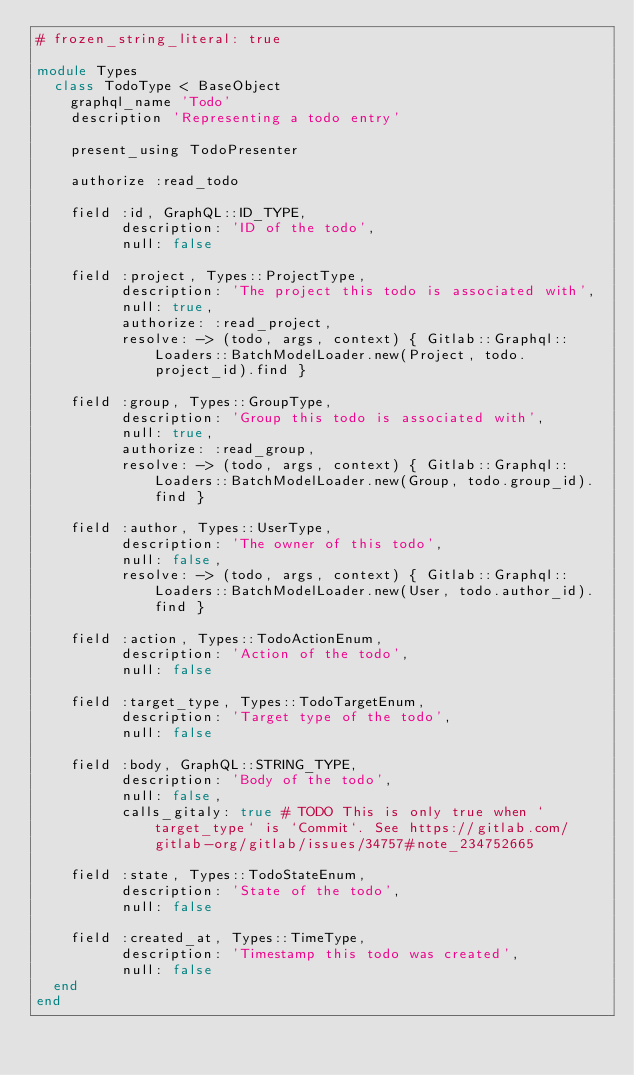<code> <loc_0><loc_0><loc_500><loc_500><_Ruby_># frozen_string_literal: true

module Types
  class TodoType < BaseObject
    graphql_name 'Todo'
    description 'Representing a todo entry'

    present_using TodoPresenter

    authorize :read_todo

    field :id, GraphQL::ID_TYPE,
          description: 'ID of the todo',
          null: false

    field :project, Types::ProjectType,
          description: 'The project this todo is associated with',
          null: true,
          authorize: :read_project,
          resolve: -> (todo, args, context) { Gitlab::Graphql::Loaders::BatchModelLoader.new(Project, todo.project_id).find }

    field :group, Types::GroupType,
          description: 'Group this todo is associated with',
          null: true,
          authorize: :read_group,
          resolve: -> (todo, args, context) { Gitlab::Graphql::Loaders::BatchModelLoader.new(Group, todo.group_id).find }

    field :author, Types::UserType,
          description: 'The owner of this todo',
          null: false,
          resolve: -> (todo, args, context) { Gitlab::Graphql::Loaders::BatchModelLoader.new(User, todo.author_id).find }

    field :action, Types::TodoActionEnum,
          description: 'Action of the todo',
          null: false

    field :target_type, Types::TodoTargetEnum,
          description: 'Target type of the todo',
          null: false

    field :body, GraphQL::STRING_TYPE,
          description: 'Body of the todo',
          null: false,
          calls_gitaly: true # TODO This is only true when `target_type` is `Commit`. See https://gitlab.com/gitlab-org/gitlab/issues/34757#note_234752665

    field :state, Types::TodoStateEnum,
          description: 'State of the todo',
          null: false

    field :created_at, Types::TimeType,
          description: 'Timestamp this todo was created',
          null: false
  end
end
</code> 